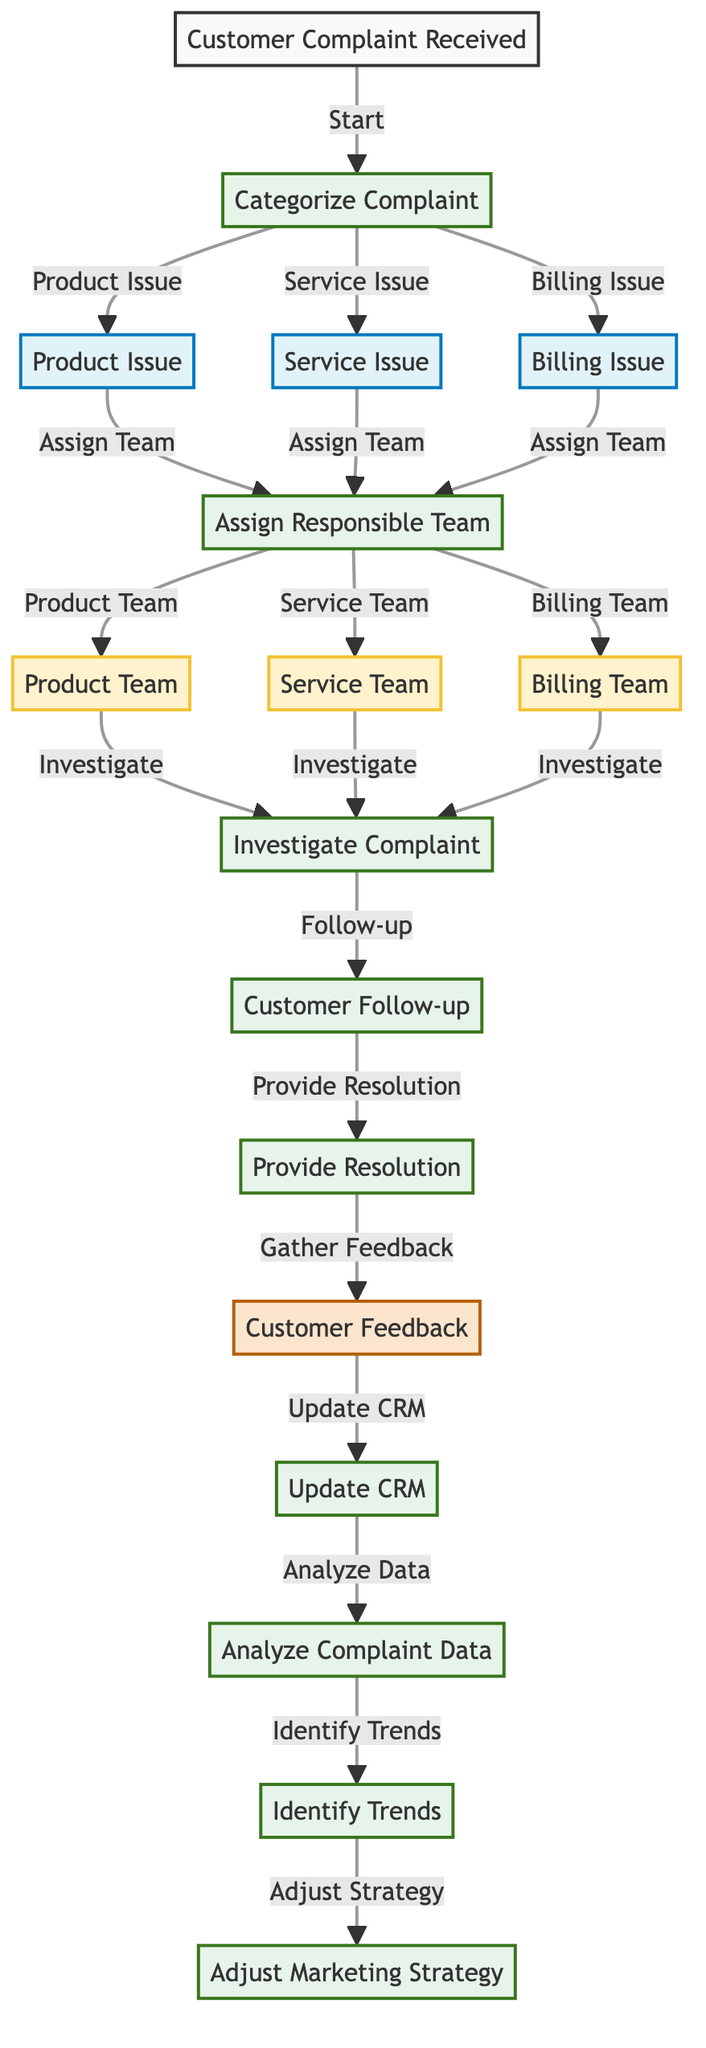What is the starting point of the complaint workflow? The diagram indicates that the workflow begins with the node labeled "Customer Complaint Received," which is directly connected as the entry point to the flow.
Answer: Customer Complaint Received How many categories of complaints are there? The diagram shows three categories: "Product Issue," "Service Issue," and "Billing Issue." This can be counted as three distinct nodes representing complaint types.
Answer: 3 Which teams are assigned based on the complaint categorization? Upon categorizing the complaints, the diagram specifies that the "Product Team," "Service Team," and "Billing Team" are assigned to investigate the respective issues.
Answer: Product Team, Service Team, Billing Team What happens after the complaint is investigated? After the "Investigate Complaint" node, the next step involves "Customer Follow-up," indicating that a follow-up occurs after the investigation phase.
Answer: Customer Follow-up How many steps are there in the complaint resolution process? The resolution process includes multiple steps: "Investigate Complaint," "Customer Follow-up," "Provide Resolution," "Customer Feedback," "Update CRM," "Analyze Complaint Data," "Identify Trends," and "Adjust Marketing Strategy." Counting these steps gives a total of seven distinct steps in the workflow.
Answer: 7 Which node comes before the "Provide Resolution"? The diagram indicates that the "Customer Follow-up" step occurs prior to providing a resolution, as shown in the sequential flow leading to resolution.
Answer: Customer Follow-up What is the final step in the complaint handling process? The final step outlined in the diagram is "Adjust Marketing Strategy," which follows the identification of trends based on complaint data analysis, marking the conclusion of the process.
Answer: Adjust Marketing Strategy How does customer feedback contribute to the workflow? The "Customer Feedback" node is central to the workflow after "Provide Resolution," and its subsequent connection to "Update CRM" suggests that feedback is processed to update records and improve future strategies.
Answer: Update CRM Which nodes are classified as processes in the diagram? The nodes classified as processes are: "Categorize Complaint," "Assign Responsible Team," "Investigate Complaint," "Customer Follow-up," "Provide Resolution," "Update CRM," "Analyze Complaint Data," "Identify Trends," and "Adjust Marketing Strategy." Counting these gives a total of eight process nodes.
Answer: 8 